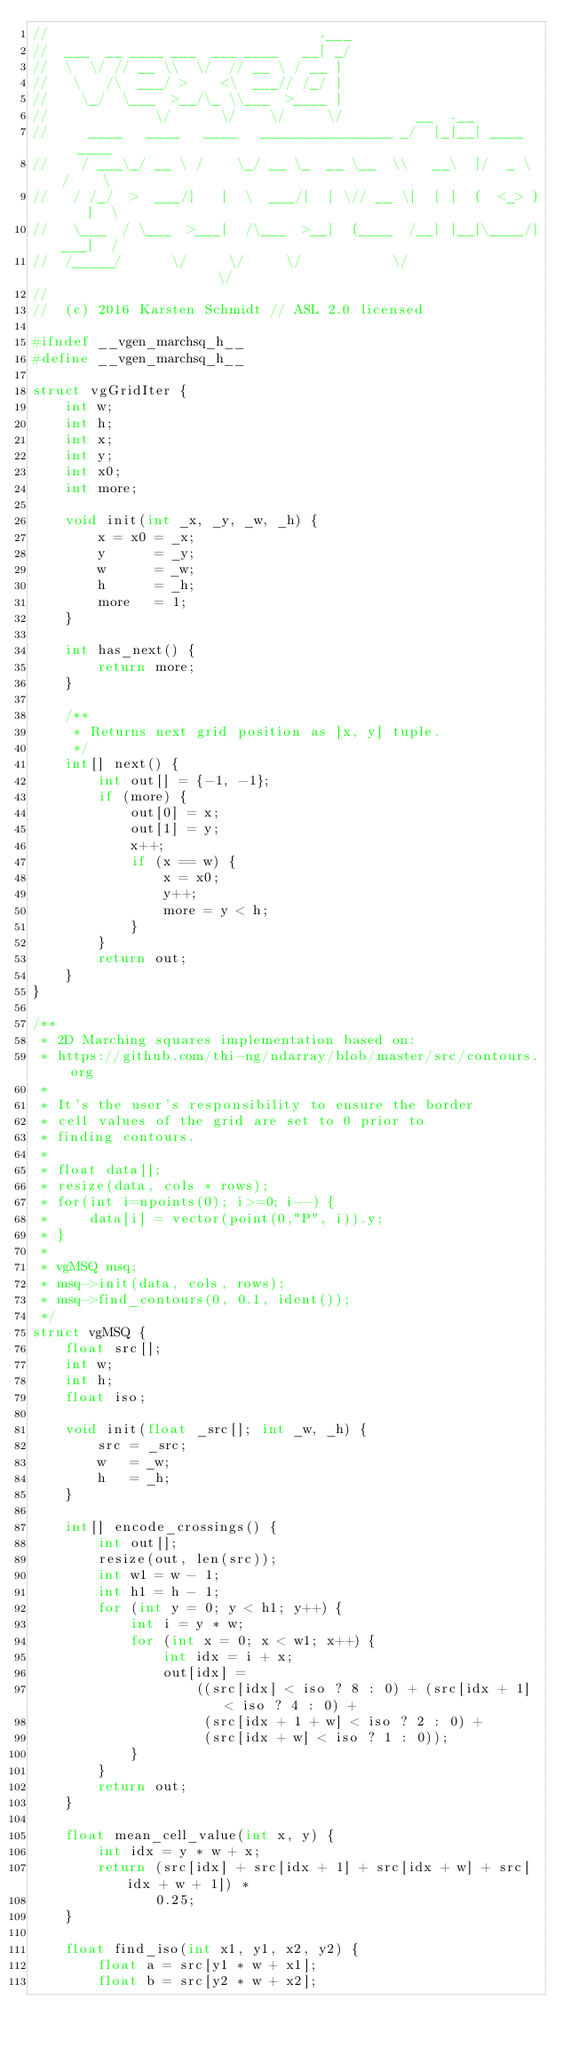<code> <loc_0><loc_0><loc_500><loc_500><_C_>//                                 .___
//  ___  __ ____ ___  ___ ____   __| _/
//  \  \/ // __ \\  \/  // __ \ / __ |
//   \   /\  ___/ >    <\  ___// /_/ |
//    \_/  \___  >__/\_ \\___  >____ |
//             \/      \/    \/     \/         __  .__
//     ____   ____   ____   ________________ _/  |_|__| ____   ____
//    / ___\_/ __ \ /    \_/ __ \_  __ \__  \\   __\  |/  _ \ /    \
//   / /_/  >  ___/|   |  \  ___/|  | \// __ \|  | |  (  <_> )   |  \
//   \___  / \___  >___|  /\___  >__|  (____  /__| |__|\____/|___|  /
//  /_____/      \/     \/     \/           \/                    \/
//
//  (c) 2016 Karsten Schmidt // ASL 2.0 licensed

#ifndef __vgen_marchsq_h__
#define __vgen_marchsq_h__

struct vgGridIter {
    int w;
    int h;
    int x;
    int y;
    int x0;
    int more;

    void init(int _x, _y, _w, _h) {
        x = x0 = _x;
        y      = _y;
        w      = _w;
        h      = _h;
        more   = 1;
    }

    int has_next() {
        return more;
    }

    /**
     * Returns next grid position as [x, y] tuple.
     */
    int[] next() {
        int out[] = {-1, -1};
        if (more) {
            out[0] = x;
            out[1] = y;
            x++;
            if (x == w) {
                x = x0;
                y++;
                more = y < h;
            }
        }
        return out;
    }
}

/**
 * 2D Marching squares implementation based on:
 * https://github.com/thi-ng/ndarray/blob/master/src/contours.org
 *
 * It's the user's responsibility to ensure the border
 * cell values of the grid are set to 0 prior to
 * finding contours.
 *
 * float data[];
 * resize(data, cols * rows);
 * for(int i=npoints(0); i>=0; i--) {
 *     data[i] = vector(point(0,"P", i)).y;
 * }
 *
 * vgMSQ msq;
 * msq->init(data, cols, rows);
 * msq->find_contours(0, 0.1, ident());
 */
struct vgMSQ {
    float src[];
    int w;
    int h;
    float iso;

    void init(float _src[]; int _w, _h) {
        src = _src;
        w   = _w;
        h   = _h;
    }

    int[] encode_crossings() {
        int out[];
        resize(out, len(src));
        int w1 = w - 1;
        int h1 = h - 1;
        for (int y = 0; y < h1; y++) {
            int i = y * w;
            for (int x = 0; x < w1; x++) {
                int idx = i + x;
                out[idx] =
                    ((src[idx] < iso ? 8 : 0) + (src[idx + 1] < iso ? 4 : 0) +
                     (src[idx + 1 + w] < iso ? 2 : 0) +
                     (src[idx + w] < iso ? 1 : 0));
            }
        }
        return out;
    }

    float mean_cell_value(int x, y) {
        int idx = y * w + x;
        return (src[idx] + src[idx + 1] + src[idx + w] + src[idx + w + 1]) *
               0.25;
    }

    float find_iso(int x1, y1, x2, y2) {
        float a = src[y1 * w + x1];
        float b = src[y2 * w + x2];</code> 